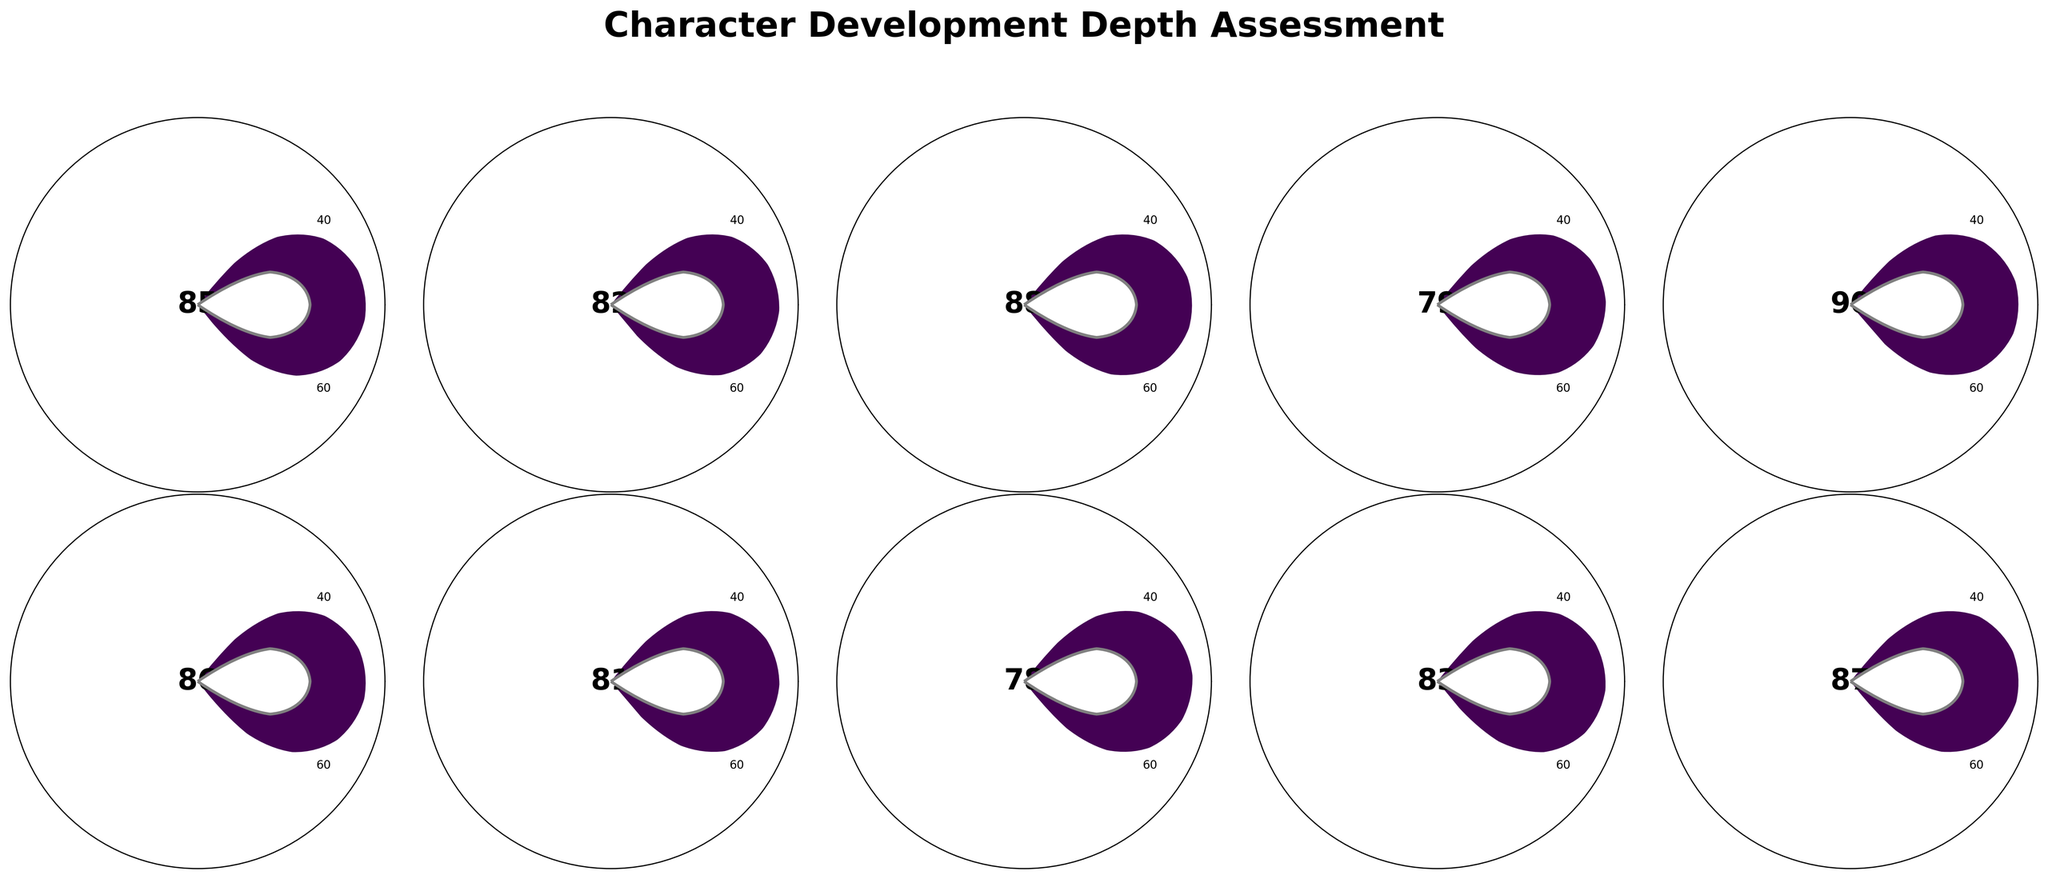What is the title of the figure? The title of the figure is written at the top and states "Character Development Depth Assessment."
Answer: Character Development Depth Assessment Which character has the highest development score? The character with the highest development score has the largest portion of their gauge filled and the highest number in the center of the gauge. Scarlett O'Hara has the highest score of 90.
Answer: Scarlett O'Hara How many characters have a development score above 85? To find the number of characters with a development score above 85, look for gauges with numbers higher than 85. Scarlett O'Hara, Rhett Butler, Jane Eyre, and Heathcliff have higher scores.
Answer: 4 What are the development scores of Elizabeth Bennet and Mr. Darcy? Locate the names "Elizabeth Bennet" and "Mr. Darcy" on their respective gauges. Elizabeth Bennet has a score of 85, and Mr. Darcy has a score of 82.
Answer: Elizabeth Bennet: 85, Mr. Darcy: 82 Who has a higher development score: Heathcliff or Catherine Earnshaw? Compare the gauges and the numbers in the center for Heathcliff and Catherine Earnshaw. Heathcliff has a score of 87, while Catherine Earnshaw has a score of 83.
Answer: Heathcliff What is the average development score of all the characters? Sum all the development scores of the characters and then divide by the total number of characters. (85 + 82 + 88 + 79 + 90 + 86 + 81 + 78 + 83 + 87) / 10 = 84.
Answer: 84 What is the development score range in the figure? Identify the highest and lowest development scores in the figure. The highest score is 90 (Scarlett O'Hara) and the lowest is 78 (Mr. Knightley). The range is 90 - 78.
Answer: 12 Which character has the least development score, and what is that score? Look for the character with the smallest portion of the gauge filled with the lowest number in the center. Mr. Knightley has the lowest score of 78.
Answer: Mr. Knightley, 78 What is the median development score of the characters? Arrange the scores in ascending order: 78, 79, 81, 82, 83, 85, 86, 87, 88, 90. There are 10 scores, so the median is the average of the 5th and 6th scores (83 + 85)/2.
Answer: 84 How much higher is Jane Eyre's development score compared to Edward Rochester's? Subtract Edward Rochester's score from Jane Eyre's score. Jane Eyre's score is 88, and Edward Rochester's is 79. 88 - 79 = 9
Answer: 9 